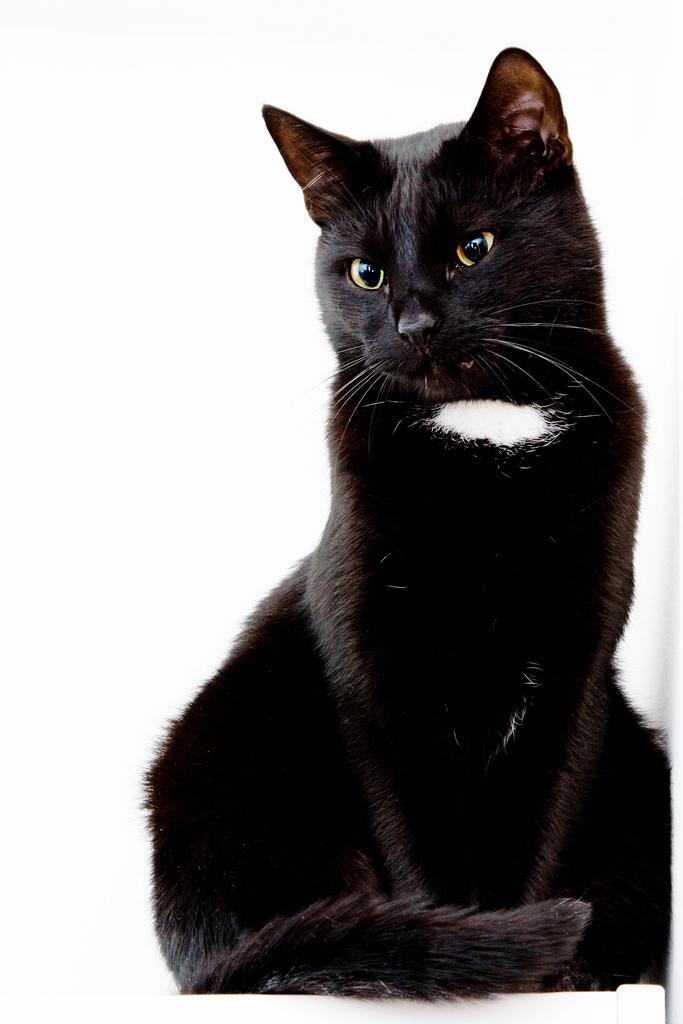Describe this image in one or two sentences. The picture consists of a black cat on a white desk. 